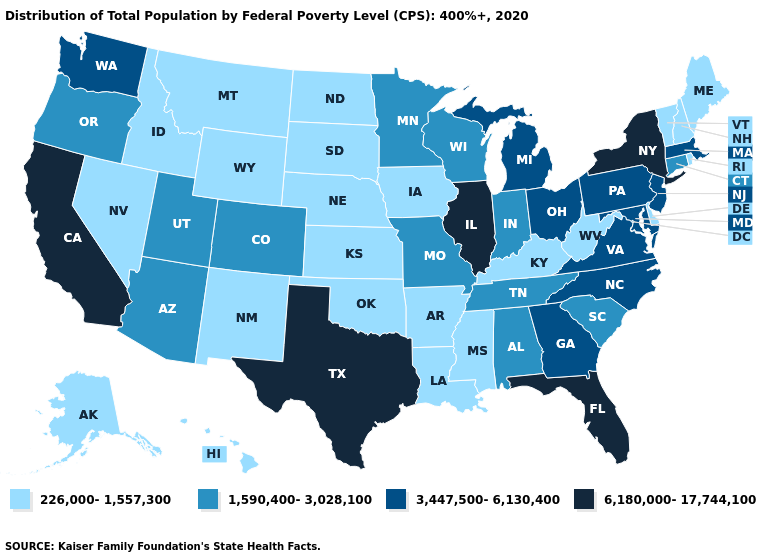What is the lowest value in the USA?
Keep it brief. 226,000-1,557,300. Among the states that border New Jersey , does Delaware have the lowest value?
Answer briefly. Yes. Which states have the lowest value in the USA?
Give a very brief answer. Alaska, Arkansas, Delaware, Hawaii, Idaho, Iowa, Kansas, Kentucky, Louisiana, Maine, Mississippi, Montana, Nebraska, Nevada, New Hampshire, New Mexico, North Dakota, Oklahoma, Rhode Island, South Dakota, Vermont, West Virginia, Wyoming. What is the value of Michigan?
Give a very brief answer. 3,447,500-6,130,400. What is the value of Oklahoma?
Write a very short answer. 226,000-1,557,300. Among the states that border Rhode Island , which have the lowest value?
Answer briefly. Connecticut. Name the states that have a value in the range 226,000-1,557,300?
Answer briefly. Alaska, Arkansas, Delaware, Hawaii, Idaho, Iowa, Kansas, Kentucky, Louisiana, Maine, Mississippi, Montana, Nebraska, Nevada, New Hampshire, New Mexico, North Dakota, Oklahoma, Rhode Island, South Dakota, Vermont, West Virginia, Wyoming. Name the states that have a value in the range 226,000-1,557,300?
Write a very short answer. Alaska, Arkansas, Delaware, Hawaii, Idaho, Iowa, Kansas, Kentucky, Louisiana, Maine, Mississippi, Montana, Nebraska, Nevada, New Hampshire, New Mexico, North Dakota, Oklahoma, Rhode Island, South Dakota, Vermont, West Virginia, Wyoming. Name the states that have a value in the range 1,590,400-3,028,100?
Give a very brief answer. Alabama, Arizona, Colorado, Connecticut, Indiana, Minnesota, Missouri, Oregon, South Carolina, Tennessee, Utah, Wisconsin. Does Iowa have the lowest value in the USA?
Be succinct. Yes. How many symbols are there in the legend?
Short answer required. 4. Which states have the lowest value in the South?
Quick response, please. Arkansas, Delaware, Kentucky, Louisiana, Mississippi, Oklahoma, West Virginia. What is the value of Missouri?
Short answer required. 1,590,400-3,028,100. Name the states that have a value in the range 6,180,000-17,744,100?
Be succinct. California, Florida, Illinois, New York, Texas. Name the states that have a value in the range 6,180,000-17,744,100?
Keep it brief. California, Florida, Illinois, New York, Texas. 